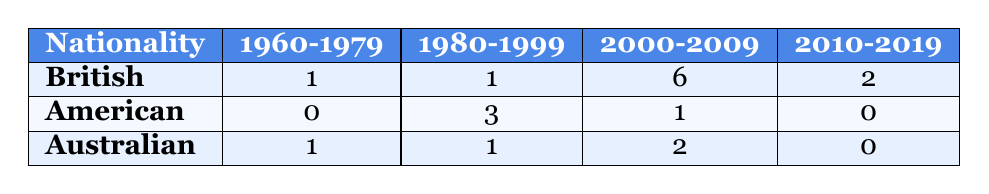What is the total number of British historical fiction bestsellers published between 2000 and 2009? The table indicates that there are 6 British books listed under the 2000-2009 column.
Answer: 6 How many American authors have published bestsellers in the 1980 to 1999 range? The table shows that there are 3 books listed under American authors in the 1980-1999 column.
Answer: 3 Did any Australian authors publish historical fiction bestsellers in the 2010 to 2019 period? The table confirms that there are 0 Australian books listed under the 2010-2019 column.
Answer: No Which nationality had the highest number of published bestsellers in the 1960 to 1979 range? British authors published 1 book in this range, American authors published 0, and Australian authors also published 1, hence British shares the highest with Australian.
Answer: British and Australian How many more bestsellers did British authors publish in the 2000 to 2009 period compared to Australian authors? British authors published 6 books, while Australian authors published 2 books in the same period. The difference is 6 - 2 = 4.
Answer: 4 What is the nationality of the author with the maximum number of bestsellers published overall in the table? Adding the totals from each nationality, British authors have 10, American authors have 4, and Australian authors have 4. British authors have the maximum published overall.
Answer: British Is it true that there are more bestsellers published by Australians than by Americans in the 2000 to 2009 range? The table shows Australians have published 2 and Americans have published 1 in this range, so it is true that Australians have more.
Answer: Yes What is the total number of bestsellers published by authors of all nationalities in the 1980 to 1999 range? The table indicates that British has 1, American has 3, and Australian has 1, resulting in a total of 1 + 3 + 1 = 5.
Answer: 5 How many years are covered in the publication years represented in the table? The years span from 1969 to 2019. The range can be calculated as 2019 - 1969 = 50 years.
Answer: 50 years Which two nationalities have the same number of bestsellers published in the 2010 to 2019 range? According to the table, both British authors (2) and Australian authors (0) have published the same number in this range, as Australian has 0 while Americans have 0.
Answer: None 